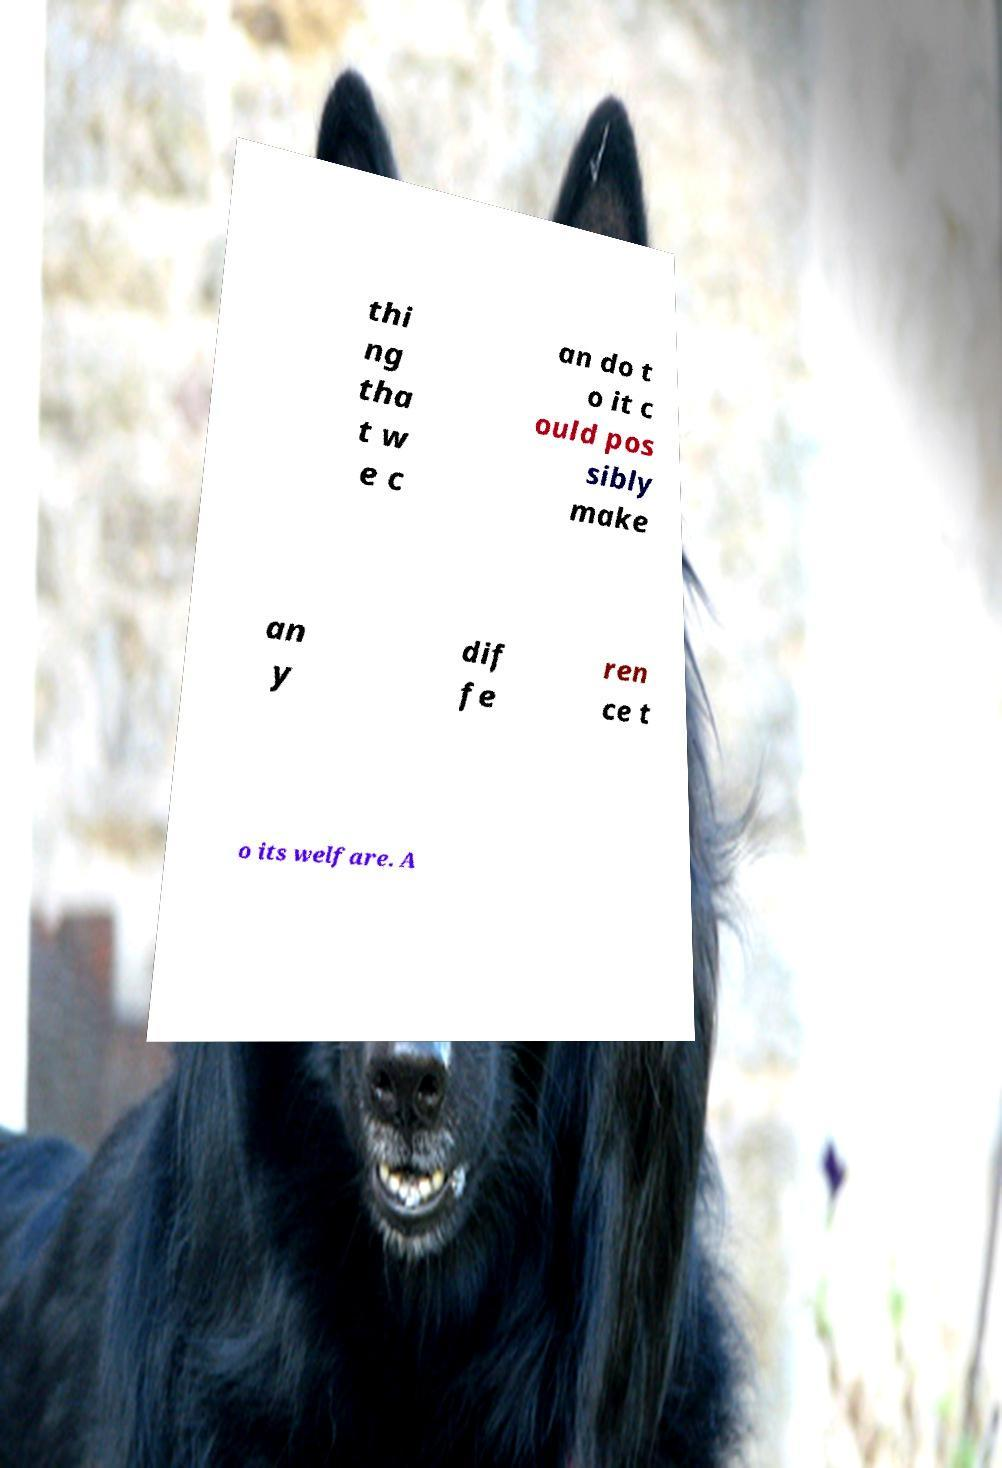What messages or text are displayed in this image? I need them in a readable, typed format. thi ng tha t w e c an do t o it c ould pos sibly make an y dif fe ren ce t o its welfare. A 